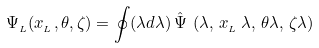Convert formula to latex. <formula><loc_0><loc_0><loc_500><loc_500>\Psi _ { _ { L } } ( x _ { _ { L } } , \theta , \zeta ) = \oint ( \lambda d \lambda ) \, \hat { \Psi } \, \left ( \lambda , \, x _ { _ { L } } \, \lambda , \, \theta \lambda , \, \zeta \lambda \right )</formula> 